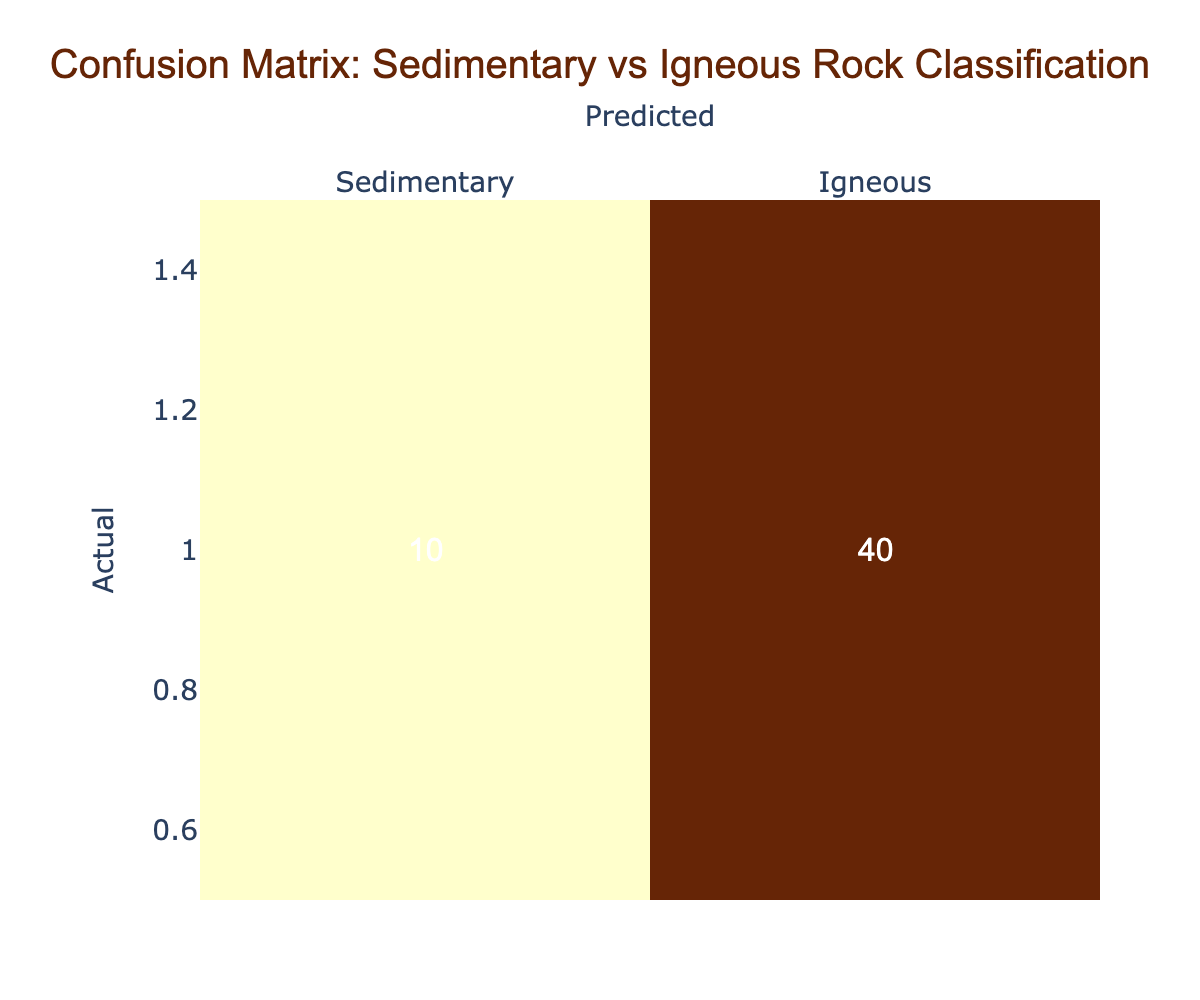What is the total number of sedimentary rock samples classified? To find the total number of sedimentary rock samples, we look at the first row of the table under the "Actual" column which is labeled "Sedimentary". The value there is 45. This value represents the correctly classified sedimentary rock samples. To find the total classified as sedimentary, we add the misclassified samples, which is 5. Therefore, the total is 45 + 5 = 50.
Answer: 50 What is the total number of igneous rock samples classified correctly? The number of igneous rock samples classified correctly is found in the second row, under the "Actual" column, labeled "Igneous". The value is 40, indicating the correctly classified igneous rock samples.
Answer: 40 How many igneous rock samples were misclassified as sedimentary? To find the number of igneous samples misclassified, we look at the second row under "Predicted" I focused on the "Sedimentary" column. The number listed there is 10, which indicates the igneous rock samples that were incorrectly classified as sedimentary.
Answer: 10 What is the total number of samples classified as sedimentary? To compute the total number of sedimentary classified samples, we need to add both the correctly classified sedimentary samples (45) and the misclassified igneous samples (10). The calculation totals 45 + 10 = 55.
Answer: 55 Is the number of correctly classified igneous samples greater than the number of misclassified sedimentary samples? The number of correctly classified igneous samples is 40, and the number of misclassified sedimentary samples is 5. Since 40 is indeed greater than 5, the answer is straightforward.
Answer: Yes What is the total number of samples in the confusion matrix? To find the total number of samples, we need to sum all elements in the confusion matrix: 45 (sedimentary correctly classified) + 5 (sedimentary misclassified) + 10 (igneous misclassified) + 40 (igneous correctly classified) = 100.
Answer: 100 What percentage of sedimentary rock samples were misclassified? To compute the percentage of misclassified sedimentary samples, we use the following formula: (number of sedimentary misclassified / total sedimentary classified) × 100. Thus, (5 / 50) × 100 = 10%.
Answer: 10% If the misclassification rates are considered, is it more significant for sedimentary or igneous rock samples? To assess this, we need to look at the misclassified counts: 5 sedimentary out of 50 total gives a rate of 10%, and 10 igneous out of 50 total gives a rate of 20%. Comparing these, 20% is greater than 10%, indicating the igneous samples have a higher misclassification rate.
Answer: Yes How many total rock samples were classified as igneous? We analyze the second row under the "Predicted" column labeled "Igneous". To find the total igneous classification, we sum the correctly classified igneous samples (40) and the misclassified sedimentary samples (10), resulting in a total of 50.
Answer: 50 